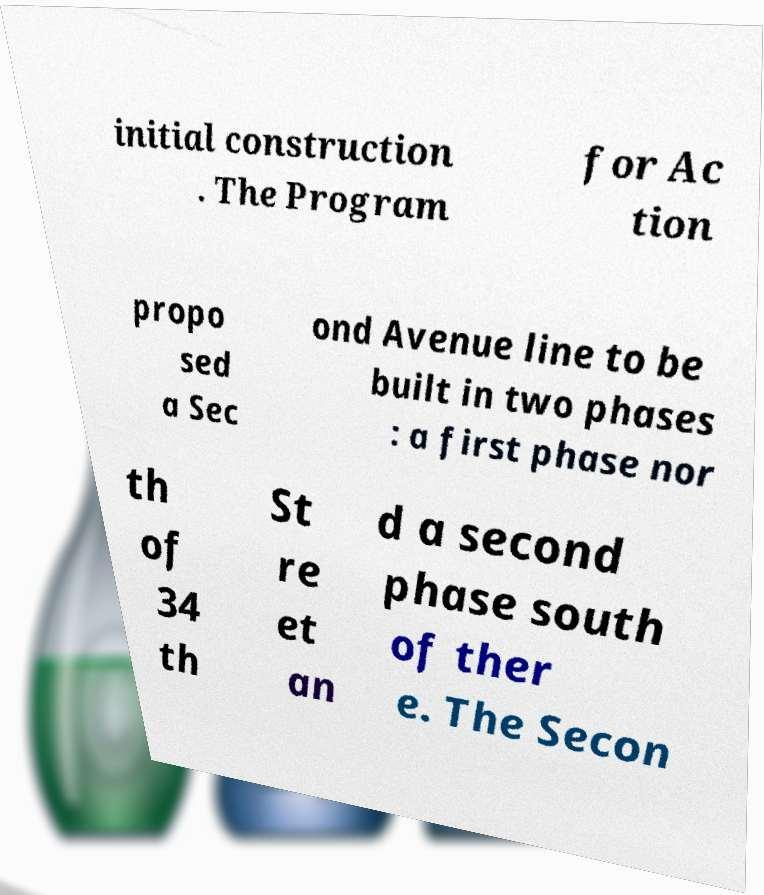What messages or text are displayed in this image? I need them in a readable, typed format. initial construction . The Program for Ac tion propo sed a Sec ond Avenue line to be built in two phases : a first phase nor th of 34 th St re et an d a second phase south of ther e. The Secon 